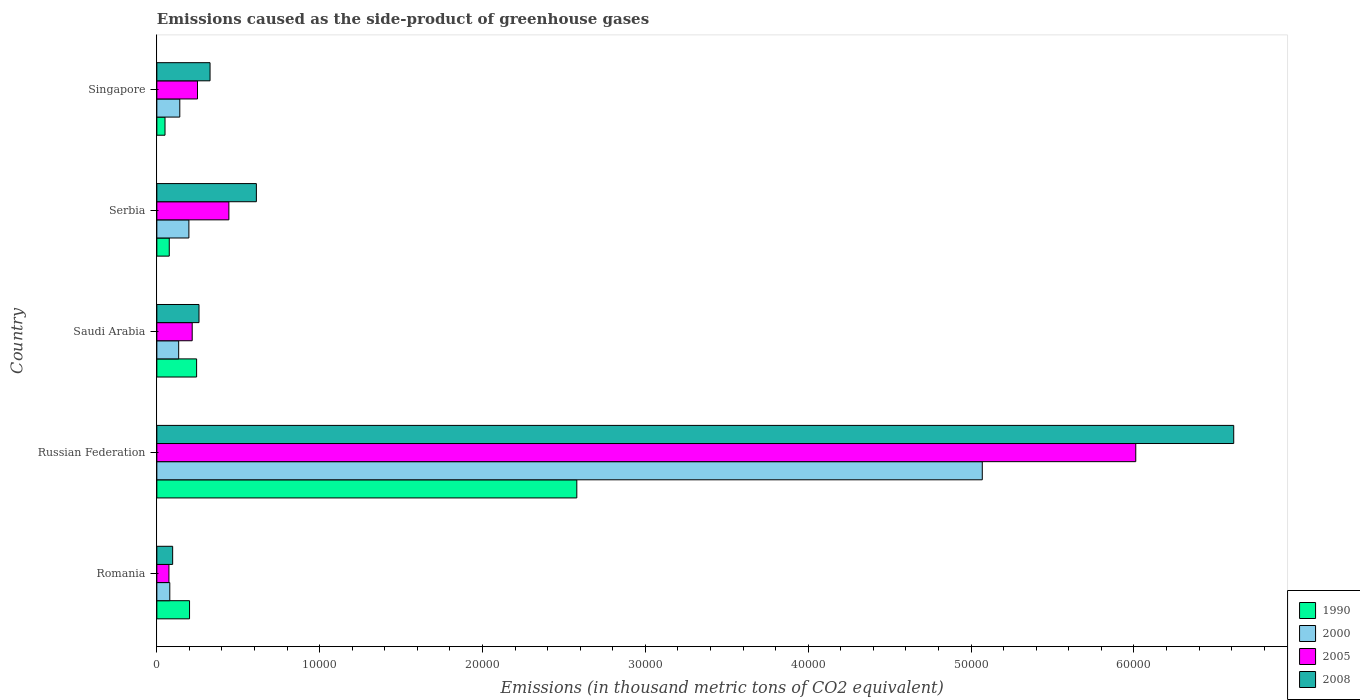How many different coloured bars are there?
Give a very brief answer. 4. What is the label of the 3rd group of bars from the top?
Offer a terse response. Saudi Arabia. What is the emissions caused as the side-product of greenhouse gases in 1990 in Russian Federation?
Keep it short and to the point. 2.58e+04. Across all countries, what is the maximum emissions caused as the side-product of greenhouse gases in 1990?
Provide a succinct answer. 2.58e+04. Across all countries, what is the minimum emissions caused as the side-product of greenhouse gases in 1990?
Provide a short and direct response. 501.5. In which country was the emissions caused as the side-product of greenhouse gases in 1990 maximum?
Provide a short and direct response. Russian Federation. In which country was the emissions caused as the side-product of greenhouse gases in 2005 minimum?
Ensure brevity in your answer.  Romania. What is the total emissions caused as the side-product of greenhouse gases in 1990 in the graph?
Your answer should be compact. 3.15e+04. What is the difference between the emissions caused as the side-product of greenhouse gases in 1990 in Russian Federation and that in Singapore?
Your answer should be compact. 2.53e+04. What is the difference between the emissions caused as the side-product of greenhouse gases in 2008 in Serbia and the emissions caused as the side-product of greenhouse gases in 1990 in Romania?
Give a very brief answer. 4103.6. What is the average emissions caused as the side-product of greenhouse gases in 1990 per country?
Your answer should be very brief. 6300.32. What is the difference between the emissions caused as the side-product of greenhouse gases in 2008 and emissions caused as the side-product of greenhouse gases in 2005 in Saudi Arabia?
Your answer should be very brief. 417.6. In how many countries, is the emissions caused as the side-product of greenhouse gases in 2008 greater than 54000 thousand metric tons?
Offer a very short reply. 1. What is the ratio of the emissions caused as the side-product of greenhouse gases in 2000 in Russian Federation to that in Serbia?
Provide a succinct answer. 25.75. Is the emissions caused as the side-product of greenhouse gases in 2000 in Serbia less than that in Singapore?
Keep it short and to the point. No. What is the difference between the highest and the second highest emissions caused as the side-product of greenhouse gases in 1990?
Offer a very short reply. 2.33e+04. What is the difference between the highest and the lowest emissions caused as the side-product of greenhouse gases in 2000?
Offer a very short reply. 4.99e+04. Is the sum of the emissions caused as the side-product of greenhouse gases in 1990 in Romania and Singapore greater than the maximum emissions caused as the side-product of greenhouse gases in 2008 across all countries?
Offer a very short reply. No. Is it the case that in every country, the sum of the emissions caused as the side-product of greenhouse gases in 2008 and emissions caused as the side-product of greenhouse gases in 2000 is greater than the sum of emissions caused as the side-product of greenhouse gases in 2005 and emissions caused as the side-product of greenhouse gases in 1990?
Your response must be concise. No. What does the 2nd bar from the bottom in Saudi Arabia represents?
Provide a short and direct response. 2000. Is it the case that in every country, the sum of the emissions caused as the side-product of greenhouse gases in 1990 and emissions caused as the side-product of greenhouse gases in 2008 is greater than the emissions caused as the side-product of greenhouse gases in 2000?
Offer a very short reply. Yes. Are all the bars in the graph horizontal?
Your response must be concise. Yes. Are the values on the major ticks of X-axis written in scientific E-notation?
Offer a very short reply. No. Does the graph contain any zero values?
Your answer should be compact. No. Where does the legend appear in the graph?
Your response must be concise. Bottom right. How many legend labels are there?
Your response must be concise. 4. What is the title of the graph?
Keep it short and to the point. Emissions caused as the side-product of greenhouse gases. What is the label or title of the X-axis?
Provide a succinct answer. Emissions (in thousand metric tons of CO2 equivalent). What is the Emissions (in thousand metric tons of CO2 equivalent) of 1990 in Romania?
Ensure brevity in your answer.  2007.7. What is the Emissions (in thousand metric tons of CO2 equivalent) of 2000 in Romania?
Ensure brevity in your answer.  795.1. What is the Emissions (in thousand metric tons of CO2 equivalent) in 2005 in Romania?
Provide a succinct answer. 742.3. What is the Emissions (in thousand metric tons of CO2 equivalent) in 2008 in Romania?
Keep it short and to the point. 970.3. What is the Emissions (in thousand metric tons of CO2 equivalent) in 1990 in Russian Federation?
Offer a very short reply. 2.58e+04. What is the Emissions (in thousand metric tons of CO2 equivalent) in 2000 in Russian Federation?
Your response must be concise. 5.07e+04. What is the Emissions (in thousand metric tons of CO2 equivalent) of 2005 in Russian Federation?
Provide a succinct answer. 6.01e+04. What is the Emissions (in thousand metric tons of CO2 equivalent) in 2008 in Russian Federation?
Your answer should be very brief. 6.61e+04. What is the Emissions (in thousand metric tons of CO2 equivalent) in 1990 in Saudi Arabia?
Give a very brief answer. 2441.4. What is the Emissions (in thousand metric tons of CO2 equivalent) in 2000 in Saudi Arabia?
Keep it short and to the point. 1340.1. What is the Emissions (in thousand metric tons of CO2 equivalent) in 2005 in Saudi Arabia?
Give a very brief answer. 2170.7. What is the Emissions (in thousand metric tons of CO2 equivalent) of 2008 in Saudi Arabia?
Your answer should be compact. 2588.3. What is the Emissions (in thousand metric tons of CO2 equivalent) in 1990 in Serbia?
Your response must be concise. 762.4. What is the Emissions (in thousand metric tons of CO2 equivalent) of 2000 in Serbia?
Your response must be concise. 1968.1. What is the Emissions (in thousand metric tons of CO2 equivalent) in 2005 in Serbia?
Your answer should be compact. 4422.8. What is the Emissions (in thousand metric tons of CO2 equivalent) in 2008 in Serbia?
Make the answer very short. 6111.3. What is the Emissions (in thousand metric tons of CO2 equivalent) in 1990 in Singapore?
Offer a very short reply. 501.5. What is the Emissions (in thousand metric tons of CO2 equivalent) in 2000 in Singapore?
Provide a succinct answer. 1409.6. What is the Emissions (in thousand metric tons of CO2 equivalent) of 2005 in Singapore?
Make the answer very short. 2496.4. What is the Emissions (in thousand metric tons of CO2 equivalent) in 2008 in Singapore?
Keep it short and to the point. 3266.4. Across all countries, what is the maximum Emissions (in thousand metric tons of CO2 equivalent) in 1990?
Your answer should be compact. 2.58e+04. Across all countries, what is the maximum Emissions (in thousand metric tons of CO2 equivalent) of 2000?
Your answer should be very brief. 5.07e+04. Across all countries, what is the maximum Emissions (in thousand metric tons of CO2 equivalent) in 2005?
Offer a very short reply. 6.01e+04. Across all countries, what is the maximum Emissions (in thousand metric tons of CO2 equivalent) of 2008?
Keep it short and to the point. 6.61e+04. Across all countries, what is the minimum Emissions (in thousand metric tons of CO2 equivalent) of 1990?
Your answer should be compact. 501.5. Across all countries, what is the minimum Emissions (in thousand metric tons of CO2 equivalent) of 2000?
Your answer should be compact. 795.1. Across all countries, what is the minimum Emissions (in thousand metric tons of CO2 equivalent) in 2005?
Provide a succinct answer. 742.3. Across all countries, what is the minimum Emissions (in thousand metric tons of CO2 equivalent) of 2008?
Provide a short and direct response. 970.3. What is the total Emissions (in thousand metric tons of CO2 equivalent) of 1990 in the graph?
Ensure brevity in your answer.  3.15e+04. What is the total Emissions (in thousand metric tons of CO2 equivalent) of 2000 in the graph?
Provide a short and direct response. 5.62e+04. What is the total Emissions (in thousand metric tons of CO2 equivalent) of 2005 in the graph?
Ensure brevity in your answer.  6.99e+04. What is the total Emissions (in thousand metric tons of CO2 equivalent) in 2008 in the graph?
Your response must be concise. 7.91e+04. What is the difference between the Emissions (in thousand metric tons of CO2 equivalent) in 1990 in Romania and that in Russian Federation?
Provide a succinct answer. -2.38e+04. What is the difference between the Emissions (in thousand metric tons of CO2 equivalent) of 2000 in Romania and that in Russian Federation?
Ensure brevity in your answer.  -4.99e+04. What is the difference between the Emissions (in thousand metric tons of CO2 equivalent) in 2005 in Romania and that in Russian Federation?
Your answer should be compact. -5.94e+04. What is the difference between the Emissions (in thousand metric tons of CO2 equivalent) in 2008 in Romania and that in Russian Federation?
Give a very brief answer. -6.52e+04. What is the difference between the Emissions (in thousand metric tons of CO2 equivalent) in 1990 in Romania and that in Saudi Arabia?
Make the answer very short. -433.7. What is the difference between the Emissions (in thousand metric tons of CO2 equivalent) of 2000 in Romania and that in Saudi Arabia?
Offer a very short reply. -545. What is the difference between the Emissions (in thousand metric tons of CO2 equivalent) of 2005 in Romania and that in Saudi Arabia?
Provide a short and direct response. -1428.4. What is the difference between the Emissions (in thousand metric tons of CO2 equivalent) in 2008 in Romania and that in Saudi Arabia?
Provide a succinct answer. -1618. What is the difference between the Emissions (in thousand metric tons of CO2 equivalent) in 1990 in Romania and that in Serbia?
Offer a terse response. 1245.3. What is the difference between the Emissions (in thousand metric tons of CO2 equivalent) in 2000 in Romania and that in Serbia?
Make the answer very short. -1173. What is the difference between the Emissions (in thousand metric tons of CO2 equivalent) of 2005 in Romania and that in Serbia?
Give a very brief answer. -3680.5. What is the difference between the Emissions (in thousand metric tons of CO2 equivalent) in 2008 in Romania and that in Serbia?
Your answer should be very brief. -5141. What is the difference between the Emissions (in thousand metric tons of CO2 equivalent) of 1990 in Romania and that in Singapore?
Your answer should be compact. 1506.2. What is the difference between the Emissions (in thousand metric tons of CO2 equivalent) of 2000 in Romania and that in Singapore?
Give a very brief answer. -614.5. What is the difference between the Emissions (in thousand metric tons of CO2 equivalent) in 2005 in Romania and that in Singapore?
Offer a very short reply. -1754.1. What is the difference between the Emissions (in thousand metric tons of CO2 equivalent) in 2008 in Romania and that in Singapore?
Offer a very short reply. -2296.1. What is the difference between the Emissions (in thousand metric tons of CO2 equivalent) of 1990 in Russian Federation and that in Saudi Arabia?
Keep it short and to the point. 2.33e+04. What is the difference between the Emissions (in thousand metric tons of CO2 equivalent) of 2000 in Russian Federation and that in Saudi Arabia?
Provide a short and direct response. 4.93e+04. What is the difference between the Emissions (in thousand metric tons of CO2 equivalent) in 2005 in Russian Federation and that in Saudi Arabia?
Provide a short and direct response. 5.79e+04. What is the difference between the Emissions (in thousand metric tons of CO2 equivalent) of 2008 in Russian Federation and that in Saudi Arabia?
Provide a short and direct response. 6.35e+04. What is the difference between the Emissions (in thousand metric tons of CO2 equivalent) in 1990 in Russian Federation and that in Serbia?
Your response must be concise. 2.50e+04. What is the difference between the Emissions (in thousand metric tons of CO2 equivalent) in 2000 in Russian Federation and that in Serbia?
Your answer should be compact. 4.87e+04. What is the difference between the Emissions (in thousand metric tons of CO2 equivalent) of 2005 in Russian Federation and that in Serbia?
Offer a terse response. 5.57e+04. What is the difference between the Emissions (in thousand metric tons of CO2 equivalent) of 2008 in Russian Federation and that in Serbia?
Your answer should be compact. 6.00e+04. What is the difference between the Emissions (in thousand metric tons of CO2 equivalent) in 1990 in Russian Federation and that in Singapore?
Offer a terse response. 2.53e+04. What is the difference between the Emissions (in thousand metric tons of CO2 equivalent) in 2000 in Russian Federation and that in Singapore?
Your response must be concise. 4.93e+04. What is the difference between the Emissions (in thousand metric tons of CO2 equivalent) of 2005 in Russian Federation and that in Singapore?
Offer a terse response. 5.76e+04. What is the difference between the Emissions (in thousand metric tons of CO2 equivalent) of 2008 in Russian Federation and that in Singapore?
Offer a terse response. 6.29e+04. What is the difference between the Emissions (in thousand metric tons of CO2 equivalent) in 1990 in Saudi Arabia and that in Serbia?
Your answer should be compact. 1679. What is the difference between the Emissions (in thousand metric tons of CO2 equivalent) in 2000 in Saudi Arabia and that in Serbia?
Your answer should be compact. -628. What is the difference between the Emissions (in thousand metric tons of CO2 equivalent) of 2005 in Saudi Arabia and that in Serbia?
Keep it short and to the point. -2252.1. What is the difference between the Emissions (in thousand metric tons of CO2 equivalent) of 2008 in Saudi Arabia and that in Serbia?
Your answer should be very brief. -3523. What is the difference between the Emissions (in thousand metric tons of CO2 equivalent) in 1990 in Saudi Arabia and that in Singapore?
Your answer should be compact. 1939.9. What is the difference between the Emissions (in thousand metric tons of CO2 equivalent) in 2000 in Saudi Arabia and that in Singapore?
Your answer should be very brief. -69.5. What is the difference between the Emissions (in thousand metric tons of CO2 equivalent) of 2005 in Saudi Arabia and that in Singapore?
Provide a succinct answer. -325.7. What is the difference between the Emissions (in thousand metric tons of CO2 equivalent) of 2008 in Saudi Arabia and that in Singapore?
Ensure brevity in your answer.  -678.1. What is the difference between the Emissions (in thousand metric tons of CO2 equivalent) of 1990 in Serbia and that in Singapore?
Ensure brevity in your answer.  260.9. What is the difference between the Emissions (in thousand metric tons of CO2 equivalent) in 2000 in Serbia and that in Singapore?
Offer a terse response. 558.5. What is the difference between the Emissions (in thousand metric tons of CO2 equivalent) of 2005 in Serbia and that in Singapore?
Give a very brief answer. 1926.4. What is the difference between the Emissions (in thousand metric tons of CO2 equivalent) of 2008 in Serbia and that in Singapore?
Keep it short and to the point. 2844.9. What is the difference between the Emissions (in thousand metric tons of CO2 equivalent) in 1990 in Romania and the Emissions (in thousand metric tons of CO2 equivalent) in 2000 in Russian Federation?
Keep it short and to the point. -4.87e+04. What is the difference between the Emissions (in thousand metric tons of CO2 equivalent) in 1990 in Romania and the Emissions (in thousand metric tons of CO2 equivalent) in 2005 in Russian Federation?
Give a very brief answer. -5.81e+04. What is the difference between the Emissions (in thousand metric tons of CO2 equivalent) of 1990 in Romania and the Emissions (in thousand metric tons of CO2 equivalent) of 2008 in Russian Federation?
Ensure brevity in your answer.  -6.41e+04. What is the difference between the Emissions (in thousand metric tons of CO2 equivalent) in 2000 in Romania and the Emissions (in thousand metric tons of CO2 equivalent) in 2005 in Russian Federation?
Give a very brief answer. -5.93e+04. What is the difference between the Emissions (in thousand metric tons of CO2 equivalent) of 2000 in Romania and the Emissions (in thousand metric tons of CO2 equivalent) of 2008 in Russian Federation?
Offer a terse response. -6.53e+04. What is the difference between the Emissions (in thousand metric tons of CO2 equivalent) of 2005 in Romania and the Emissions (in thousand metric tons of CO2 equivalent) of 2008 in Russian Federation?
Your answer should be compact. -6.54e+04. What is the difference between the Emissions (in thousand metric tons of CO2 equivalent) in 1990 in Romania and the Emissions (in thousand metric tons of CO2 equivalent) in 2000 in Saudi Arabia?
Provide a short and direct response. 667.6. What is the difference between the Emissions (in thousand metric tons of CO2 equivalent) in 1990 in Romania and the Emissions (in thousand metric tons of CO2 equivalent) in 2005 in Saudi Arabia?
Offer a terse response. -163. What is the difference between the Emissions (in thousand metric tons of CO2 equivalent) in 1990 in Romania and the Emissions (in thousand metric tons of CO2 equivalent) in 2008 in Saudi Arabia?
Your answer should be compact. -580.6. What is the difference between the Emissions (in thousand metric tons of CO2 equivalent) of 2000 in Romania and the Emissions (in thousand metric tons of CO2 equivalent) of 2005 in Saudi Arabia?
Give a very brief answer. -1375.6. What is the difference between the Emissions (in thousand metric tons of CO2 equivalent) in 2000 in Romania and the Emissions (in thousand metric tons of CO2 equivalent) in 2008 in Saudi Arabia?
Provide a succinct answer. -1793.2. What is the difference between the Emissions (in thousand metric tons of CO2 equivalent) of 2005 in Romania and the Emissions (in thousand metric tons of CO2 equivalent) of 2008 in Saudi Arabia?
Your answer should be compact. -1846. What is the difference between the Emissions (in thousand metric tons of CO2 equivalent) in 1990 in Romania and the Emissions (in thousand metric tons of CO2 equivalent) in 2000 in Serbia?
Make the answer very short. 39.6. What is the difference between the Emissions (in thousand metric tons of CO2 equivalent) in 1990 in Romania and the Emissions (in thousand metric tons of CO2 equivalent) in 2005 in Serbia?
Your answer should be very brief. -2415.1. What is the difference between the Emissions (in thousand metric tons of CO2 equivalent) in 1990 in Romania and the Emissions (in thousand metric tons of CO2 equivalent) in 2008 in Serbia?
Keep it short and to the point. -4103.6. What is the difference between the Emissions (in thousand metric tons of CO2 equivalent) of 2000 in Romania and the Emissions (in thousand metric tons of CO2 equivalent) of 2005 in Serbia?
Make the answer very short. -3627.7. What is the difference between the Emissions (in thousand metric tons of CO2 equivalent) of 2000 in Romania and the Emissions (in thousand metric tons of CO2 equivalent) of 2008 in Serbia?
Your response must be concise. -5316.2. What is the difference between the Emissions (in thousand metric tons of CO2 equivalent) in 2005 in Romania and the Emissions (in thousand metric tons of CO2 equivalent) in 2008 in Serbia?
Make the answer very short. -5369. What is the difference between the Emissions (in thousand metric tons of CO2 equivalent) in 1990 in Romania and the Emissions (in thousand metric tons of CO2 equivalent) in 2000 in Singapore?
Offer a terse response. 598.1. What is the difference between the Emissions (in thousand metric tons of CO2 equivalent) of 1990 in Romania and the Emissions (in thousand metric tons of CO2 equivalent) of 2005 in Singapore?
Offer a terse response. -488.7. What is the difference between the Emissions (in thousand metric tons of CO2 equivalent) in 1990 in Romania and the Emissions (in thousand metric tons of CO2 equivalent) in 2008 in Singapore?
Your response must be concise. -1258.7. What is the difference between the Emissions (in thousand metric tons of CO2 equivalent) of 2000 in Romania and the Emissions (in thousand metric tons of CO2 equivalent) of 2005 in Singapore?
Your answer should be very brief. -1701.3. What is the difference between the Emissions (in thousand metric tons of CO2 equivalent) of 2000 in Romania and the Emissions (in thousand metric tons of CO2 equivalent) of 2008 in Singapore?
Ensure brevity in your answer.  -2471.3. What is the difference between the Emissions (in thousand metric tons of CO2 equivalent) in 2005 in Romania and the Emissions (in thousand metric tons of CO2 equivalent) in 2008 in Singapore?
Ensure brevity in your answer.  -2524.1. What is the difference between the Emissions (in thousand metric tons of CO2 equivalent) of 1990 in Russian Federation and the Emissions (in thousand metric tons of CO2 equivalent) of 2000 in Saudi Arabia?
Your response must be concise. 2.44e+04. What is the difference between the Emissions (in thousand metric tons of CO2 equivalent) of 1990 in Russian Federation and the Emissions (in thousand metric tons of CO2 equivalent) of 2005 in Saudi Arabia?
Ensure brevity in your answer.  2.36e+04. What is the difference between the Emissions (in thousand metric tons of CO2 equivalent) in 1990 in Russian Federation and the Emissions (in thousand metric tons of CO2 equivalent) in 2008 in Saudi Arabia?
Make the answer very short. 2.32e+04. What is the difference between the Emissions (in thousand metric tons of CO2 equivalent) of 2000 in Russian Federation and the Emissions (in thousand metric tons of CO2 equivalent) of 2005 in Saudi Arabia?
Ensure brevity in your answer.  4.85e+04. What is the difference between the Emissions (in thousand metric tons of CO2 equivalent) of 2000 in Russian Federation and the Emissions (in thousand metric tons of CO2 equivalent) of 2008 in Saudi Arabia?
Give a very brief answer. 4.81e+04. What is the difference between the Emissions (in thousand metric tons of CO2 equivalent) of 2005 in Russian Federation and the Emissions (in thousand metric tons of CO2 equivalent) of 2008 in Saudi Arabia?
Your response must be concise. 5.75e+04. What is the difference between the Emissions (in thousand metric tons of CO2 equivalent) of 1990 in Russian Federation and the Emissions (in thousand metric tons of CO2 equivalent) of 2000 in Serbia?
Your answer should be very brief. 2.38e+04. What is the difference between the Emissions (in thousand metric tons of CO2 equivalent) in 1990 in Russian Federation and the Emissions (in thousand metric tons of CO2 equivalent) in 2005 in Serbia?
Your response must be concise. 2.14e+04. What is the difference between the Emissions (in thousand metric tons of CO2 equivalent) of 1990 in Russian Federation and the Emissions (in thousand metric tons of CO2 equivalent) of 2008 in Serbia?
Your answer should be very brief. 1.97e+04. What is the difference between the Emissions (in thousand metric tons of CO2 equivalent) of 2000 in Russian Federation and the Emissions (in thousand metric tons of CO2 equivalent) of 2005 in Serbia?
Give a very brief answer. 4.63e+04. What is the difference between the Emissions (in thousand metric tons of CO2 equivalent) of 2000 in Russian Federation and the Emissions (in thousand metric tons of CO2 equivalent) of 2008 in Serbia?
Your response must be concise. 4.46e+04. What is the difference between the Emissions (in thousand metric tons of CO2 equivalent) in 2005 in Russian Federation and the Emissions (in thousand metric tons of CO2 equivalent) in 2008 in Serbia?
Keep it short and to the point. 5.40e+04. What is the difference between the Emissions (in thousand metric tons of CO2 equivalent) of 1990 in Russian Federation and the Emissions (in thousand metric tons of CO2 equivalent) of 2000 in Singapore?
Your answer should be compact. 2.44e+04. What is the difference between the Emissions (in thousand metric tons of CO2 equivalent) of 1990 in Russian Federation and the Emissions (in thousand metric tons of CO2 equivalent) of 2005 in Singapore?
Your answer should be very brief. 2.33e+04. What is the difference between the Emissions (in thousand metric tons of CO2 equivalent) in 1990 in Russian Federation and the Emissions (in thousand metric tons of CO2 equivalent) in 2008 in Singapore?
Your answer should be very brief. 2.25e+04. What is the difference between the Emissions (in thousand metric tons of CO2 equivalent) of 2000 in Russian Federation and the Emissions (in thousand metric tons of CO2 equivalent) of 2005 in Singapore?
Offer a very short reply. 4.82e+04. What is the difference between the Emissions (in thousand metric tons of CO2 equivalent) of 2000 in Russian Federation and the Emissions (in thousand metric tons of CO2 equivalent) of 2008 in Singapore?
Provide a short and direct response. 4.74e+04. What is the difference between the Emissions (in thousand metric tons of CO2 equivalent) in 2005 in Russian Federation and the Emissions (in thousand metric tons of CO2 equivalent) in 2008 in Singapore?
Ensure brevity in your answer.  5.68e+04. What is the difference between the Emissions (in thousand metric tons of CO2 equivalent) of 1990 in Saudi Arabia and the Emissions (in thousand metric tons of CO2 equivalent) of 2000 in Serbia?
Ensure brevity in your answer.  473.3. What is the difference between the Emissions (in thousand metric tons of CO2 equivalent) in 1990 in Saudi Arabia and the Emissions (in thousand metric tons of CO2 equivalent) in 2005 in Serbia?
Keep it short and to the point. -1981.4. What is the difference between the Emissions (in thousand metric tons of CO2 equivalent) in 1990 in Saudi Arabia and the Emissions (in thousand metric tons of CO2 equivalent) in 2008 in Serbia?
Your answer should be very brief. -3669.9. What is the difference between the Emissions (in thousand metric tons of CO2 equivalent) of 2000 in Saudi Arabia and the Emissions (in thousand metric tons of CO2 equivalent) of 2005 in Serbia?
Provide a succinct answer. -3082.7. What is the difference between the Emissions (in thousand metric tons of CO2 equivalent) of 2000 in Saudi Arabia and the Emissions (in thousand metric tons of CO2 equivalent) of 2008 in Serbia?
Offer a terse response. -4771.2. What is the difference between the Emissions (in thousand metric tons of CO2 equivalent) of 2005 in Saudi Arabia and the Emissions (in thousand metric tons of CO2 equivalent) of 2008 in Serbia?
Provide a short and direct response. -3940.6. What is the difference between the Emissions (in thousand metric tons of CO2 equivalent) of 1990 in Saudi Arabia and the Emissions (in thousand metric tons of CO2 equivalent) of 2000 in Singapore?
Offer a terse response. 1031.8. What is the difference between the Emissions (in thousand metric tons of CO2 equivalent) of 1990 in Saudi Arabia and the Emissions (in thousand metric tons of CO2 equivalent) of 2005 in Singapore?
Give a very brief answer. -55. What is the difference between the Emissions (in thousand metric tons of CO2 equivalent) in 1990 in Saudi Arabia and the Emissions (in thousand metric tons of CO2 equivalent) in 2008 in Singapore?
Ensure brevity in your answer.  -825. What is the difference between the Emissions (in thousand metric tons of CO2 equivalent) of 2000 in Saudi Arabia and the Emissions (in thousand metric tons of CO2 equivalent) of 2005 in Singapore?
Your answer should be compact. -1156.3. What is the difference between the Emissions (in thousand metric tons of CO2 equivalent) of 2000 in Saudi Arabia and the Emissions (in thousand metric tons of CO2 equivalent) of 2008 in Singapore?
Ensure brevity in your answer.  -1926.3. What is the difference between the Emissions (in thousand metric tons of CO2 equivalent) of 2005 in Saudi Arabia and the Emissions (in thousand metric tons of CO2 equivalent) of 2008 in Singapore?
Offer a terse response. -1095.7. What is the difference between the Emissions (in thousand metric tons of CO2 equivalent) of 1990 in Serbia and the Emissions (in thousand metric tons of CO2 equivalent) of 2000 in Singapore?
Offer a very short reply. -647.2. What is the difference between the Emissions (in thousand metric tons of CO2 equivalent) of 1990 in Serbia and the Emissions (in thousand metric tons of CO2 equivalent) of 2005 in Singapore?
Your answer should be compact. -1734. What is the difference between the Emissions (in thousand metric tons of CO2 equivalent) in 1990 in Serbia and the Emissions (in thousand metric tons of CO2 equivalent) in 2008 in Singapore?
Make the answer very short. -2504. What is the difference between the Emissions (in thousand metric tons of CO2 equivalent) in 2000 in Serbia and the Emissions (in thousand metric tons of CO2 equivalent) in 2005 in Singapore?
Make the answer very short. -528.3. What is the difference between the Emissions (in thousand metric tons of CO2 equivalent) of 2000 in Serbia and the Emissions (in thousand metric tons of CO2 equivalent) of 2008 in Singapore?
Make the answer very short. -1298.3. What is the difference between the Emissions (in thousand metric tons of CO2 equivalent) of 2005 in Serbia and the Emissions (in thousand metric tons of CO2 equivalent) of 2008 in Singapore?
Ensure brevity in your answer.  1156.4. What is the average Emissions (in thousand metric tons of CO2 equivalent) in 1990 per country?
Offer a very short reply. 6300.32. What is the average Emissions (in thousand metric tons of CO2 equivalent) in 2000 per country?
Offer a terse response. 1.12e+04. What is the average Emissions (in thousand metric tons of CO2 equivalent) of 2005 per country?
Keep it short and to the point. 1.40e+04. What is the average Emissions (in thousand metric tons of CO2 equivalent) of 2008 per country?
Your answer should be compact. 1.58e+04. What is the difference between the Emissions (in thousand metric tons of CO2 equivalent) in 1990 and Emissions (in thousand metric tons of CO2 equivalent) in 2000 in Romania?
Provide a succinct answer. 1212.6. What is the difference between the Emissions (in thousand metric tons of CO2 equivalent) in 1990 and Emissions (in thousand metric tons of CO2 equivalent) in 2005 in Romania?
Ensure brevity in your answer.  1265.4. What is the difference between the Emissions (in thousand metric tons of CO2 equivalent) of 1990 and Emissions (in thousand metric tons of CO2 equivalent) of 2008 in Romania?
Keep it short and to the point. 1037.4. What is the difference between the Emissions (in thousand metric tons of CO2 equivalent) in 2000 and Emissions (in thousand metric tons of CO2 equivalent) in 2005 in Romania?
Offer a very short reply. 52.8. What is the difference between the Emissions (in thousand metric tons of CO2 equivalent) of 2000 and Emissions (in thousand metric tons of CO2 equivalent) of 2008 in Romania?
Your response must be concise. -175.2. What is the difference between the Emissions (in thousand metric tons of CO2 equivalent) in 2005 and Emissions (in thousand metric tons of CO2 equivalent) in 2008 in Romania?
Give a very brief answer. -228. What is the difference between the Emissions (in thousand metric tons of CO2 equivalent) of 1990 and Emissions (in thousand metric tons of CO2 equivalent) of 2000 in Russian Federation?
Provide a short and direct response. -2.49e+04. What is the difference between the Emissions (in thousand metric tons of CO2 equivalent) of 1990 and Emissions (in thousand metric tons of CO2 equivalent) of 2005 in Russian Federation?
Give a very brief answer. -3.43e+04. What is the difference between the Emissions (in thousand metric tons of CO2 equivalent) in 1990 and Emissions (in thousand metric tons of CO2 equivalent) in 2008 in Russian Federation?
Make the answer very short. -4.03e+04. What is the difference between the Emissions (in thousand metric tons of CO2 equivalent) of 2000 and Emissions (in thousand metric tons of CO2 equivalent) of 2005 in Russian Federation?
Offer a terse response. -9424.5. What is the difference between the Emissions (in thousand metric tons of CO2 equivalent) in 2000 and Emissions (in thousand metric tons of CO2 equivalent) in 2008 in Russian Federation?
Keep it short and to the point. -1.54e+04. What is the difference between the Emissions (in thousand metric tons of CO2 equivalent) in 2005 and Emissions (in thousand metric tons of CO2 equivalent) in 2008 in Russian Federation?
Offer a terse response. -6015. What is the difference between the Emissions (in thousand metric tons of CO2 equivalent) of 1990 and Emissions (in thousand metric tons of CO2 equivalent) of 2000 in Saudi Arabia?
Offer a very short reply. 1101.3. What is the difference between the Emissions (in thousand metric tons of CO2 equivalent) in 1990 and Emissions (in thousand metric tons of CO2 equivalent) in 2005 in Saudi Arabia?
Offer a very short reply. 270.7. What is the difference between the Emissions (in thousand metric tons of CO2 equivalent) in 1990 and Emissions (in thousand metric tons of CO2 equivalent) in 2008 in Saudi Arabia?
Make the answer very short. -146.9. What is the difference between the Emissions (in thousand metric tons of CO2 equivalent) of 2000 and Emissions (in thousand metric tons of CO2 equivalent) of 2005 in Saudi Arabia?
Make the answer very short. -830.6. What is the difference between the Emissions (in thousand metric tons of CO2 equivalent) of 2000 and Emissions (in thousand metric tons of CO2 equivalent) of 2008 in Saudi Arabia?
Your response must be concise. -1248.2. What is the difference between the Emissions (in thousand metric tons of CO2 equivalent) of 2005 and Emissions (in thousand metric tons of CO2 equivalent) of 2008 in Saudi Arabia?
Your response must be concise. -417.6. What is the difference between the Emissions (in thousand metric tons of CO2 equivalent) in 1990 and Emissions (in thousand metric tons of CO2 equivalent) in 2000 in Serbia?
Give a very brief answer. -1205.7. What is the difference between the Emissions (in thousand metric tons of CO2 equivalent) in 1990 and Emissions (in thousand metric tons of CO2 equivalent) in 2005 in Serbia?
Make the answer very short. -3660.4. What is the difference between the Emissions (in thousand metric tons of CO2 equivalent) in 1990 and Emissions (in thousand metric tons of CO2 equivalent) in 2008 in Serbia?
Give a very brief answer. -5348.9. What is the difference between the Emissions (in thousand metric tons of CO2 equivalent) in 2000 and Emissions (in thousand metric tons of CO2 equivalent) in 2005 in Serbia?
Ensure brevity in your answer.  -2454.7. What is the difference between the Emissions (in thousand metric tons of CO2 equivalent) in 2000 and Emissions (in thousand metric tons of CO2 equivalent) in 2008 in Serbia?
Your response must be concise. -4143.2. What is the difference between the Emissions (in thousand metric tons of CO2 equivalent) of 2005 and Emissions (in thousand metric tons of CO2 equivalent) of 2008 in Serbia?
Provide a short and direct response. -1688.5. What is the difference between the Emissions (in thousand metric tons of CO2 equivalent) of 1990 and Emissions (in thousand metric tons of CO2 equivalent) of 2000 in Singapore?
Your answer should be very brief. -908.1. What is the difference between the Emissions (in thousand metric tons of CO2 equivalent) in 1990 and Emissions (in thousand metric tons of CO2 equivalent) in 2005 in Singapore?
Make the answer very short. -1994.9. What is the difference between the Emissions (in thousand metric tons of CO2 equivalent) in 1990 and Emissions (in thousand metric tons of CO2 equivalent) in 2008 in Singapore?
Provide a succinct answer. -2764.9. What is the difference between the Emissions (in thousand metric tons of CO2 equivalent) in 2000 and Emissions (in thousand metric tons of CO2 equivalent) in 2005 in Singapore?
Your response must be concise. -1086.8. What is the difference between the Emissions (in thousand metric tons of CO2 equivalent) in 2000 and Emissions (in thousand metric tons of CO2 equivalent) in 2008 in Singapore?
Give a very brief answer. -1856.8. What is the difference between the Emissions (in thousand metric tons of CO2 equivalent) of 2005 and Emissions (in thousand metric tons of CO2 equivalent) of 2008 in Singapore?
Provide a short and direct response. -770. What is the ratio of the Emissions (in thousand metric tons of CO2 equivalent) of 1990 in Romania to that in Russian Federation?
Offer a very short reply. 0.08. What is the ratio of the Emissions (in thousand metric tons of CO2 equivalent) in 2000 in Romania to that in Russian Federation?
Provide a succinct answer. 0.02. What is the ratio of the Emissions (in thousand metric tons of CO2 equivalent) in 2005 in Romania to that in Russian Federation?
Offer a very short reply. 0.01. What is the ratio of the Emissions (in thousand metric tons of CO2 equivalent) in 2008 in Romania to that in Russian Federation?
Offer a very short reply. 0.01. What is the ratio of the Emissions (in thousand metric tons of CO2 equivalent) of 1990 in Romania to that in Saudi Arabia?
Provide a succinct answer. 0.82. What is the ratio of the Emissions (in thousand metric tons of CO2 equivalent) in 2000 in Romania to that in Saudi Arabia?
Your answer should be compact. 0.59. What is the ratio of the Emissions (in thousand metric tons of CO2 equivalent) of 2005 in Romania to that in Saudi Arabia?
Give a very brief answer. 0.34. What is the ratio of the Emissions (in thousand metric tons of CO2 equivalent) of 2008 in Romania to that in Saudi Arabia?
Give a very brief answer. 0.37. What is the ratio of the Emissions (in thousand metric tons of CO2 equivalent) in 1990 in Romania to that in Serbia?
Your answer should be compact. 2.63. What is the ratio of the Emissions (in thousand metric tons of CO2 equivalent) in 2000 in Romania to that in Serbia?
Ensure brevity in your answer.  0.4. What is the ratio of the Emissions (in thousand metric tons of CO2 equivalent) of 2005 in Romania to that in Serbia?
Offer a terse response. 0.17. What is the ratio of the Emissions (in thousand metric tons of CO2 equivalent) of 2008 in Romania to that in Serbia?
Offer a very short reply. 0.16. What is the ratio of the Emissions (in thousand metric tons of CO2 equivalent) of 1990 in Romania to that in Singapore?
Your answer should be compact. 4. What is the ratio of the Emissions (in thousand metric tons of CO2 equivalent) in 2000 in Romania to that in Singapore?
Your answer should be compact. 0.56. What is the ratio of the Emissions (in thousand metric tons of CO2 equivalent) of 2005 in Romania to that in Singapore?
Your answer should be compact. 0.3. What is the ratio of the Emissions (in thousand metric tons of CO2 equivalent) of 2008 in Romania to that in Singapore?
Offer a very short reply. 0.3. What is the ratio of the Emissions (in thousand metric tons of CO2 equivalent) in 1990 in Russian Federation to that in Saudi Arabia?
Give a very brief answer. 10.56. What is the ratio of the Emissions (in thousand metric tons of CO2 equivalent) of 2000 in Russian Federation to that in Saudi Arabia?
Provide a short and direct response. 37.82. What is the ratio of the Emissions (in thousand metric tons of CO2 equivalent) in 2005 in Russian Federation to that in Saudi Arabia?
Your answer should be very brief. 27.69. What is the ratio of the Emissions (in thousand metric tons of CO2 equivalent) of 2008 in Russian Federation to that in Saudi Arabia?
Ensure brevity in your answer.  25.55. What is the ratio of the Emissions (in thousand metric tons of CO2 equivalent) in 1990 in Russian Federation to that in Serbia?
Your answer should be compact. 33.83. What is the ratio of the Emissions (in thousand metric tons of CO2 equivalent) of 2000 in Russian Federation to that in Serbia?
Offer a terse response. 25.75. What is the ratio of the Emissions (in thousand metric tons of CO2 equivalent) in 2005 in Russian Federation to that in Serbia?
Offer a very short reply. 13.59. What is the ratio of the Emissions (in thousand metric tons of CO2 equivalent) in 2008 in Russian Federation to that in Serbia?
Offer a very short reply. 10.82. What is the ratio of the Emissions (in thousand metric tons of CO2 equivalent) of 1990 in Russian Federation to that in Singapore?
Offer a terse response. 51.42. What is the ratio of the Emissions (in thousand metric tons of CO2 equivalent) in 2000 in Russian Federation to that in Singapore?
Your response must be concise. 35.96. What is the ratio of the Emissions (in thousand metric tons of CO2 equivalent) in 2005 in Russian Federation to that in Singapore?
Your answer should be compact. 24.08. What is the ratio of the Emissions (in thousand metric tons of CO2 equivalent) in 2008 in Russian Federation to that in Singapore?
Keep it short and to the point. 20.24. What is the ratio of the Emissions (in thousand metric tons of CO2 equivalent) of 1990 in Saudi Arabia to that in Serbia?
Your response must be concise. 3.2. What is the ratio of the Emissions (in thousand metric tons of CO2 equivalent) of 2000 in Saudi Arabia to that in Serbia?
Make the answer very short. 0.68. What is the ratio of the Emissions (in thousand metric tons of CO2 equivalent) in 2005 in Saudi Arabia to that in Serbia?
Your answer should be compact. 0.49. What is the ratio of the Emissions (in thousand metric tons of CO2 equivalent) in 2008 in Saudi Arabia to that in Serbia?
Your answer should be compact. 0.42. What is the ratio of the Emissions (in thousand metric tons of CO2 equivalent) of 1990 in Saudi Arabia to that in Singapore?
Provide a succinct answer. 4.87. What is the ratio of the Emissions (in thousand metric tons of CO2 equivalent) of 2000 in Saudi Arabia to that in Singapore?
Provide a succinct answer. 0.95. What is the ratio of the Emissions (in thousand metric tons of CO2 equivalent) of 2005 in Saudi Arabia to that in Singapore?
Ensure brevity in your answer.  0.87. What is the ratio of the Emissions (in thousand metric tons of CO2 equivalent) in 2008 in Saudi Arabia to that in Singapore?
Ensure brevity in your answer.  0.79. What is the ratio of the Emissions (in thousand metric tons of CO2 equivalent) of 1990 in Serbia to that in Singapore?
Keep it short and to the point. 1.52. What is the ratio of the Emissions (in thousand metric tons of CO2 equivalent) in 2000 in Serbia to that in Singapore?
Keep it short and to the point. 1.4. What is the ratio of the Emissions (in thousand metric tons of CO2 equivalent) of 2005 in Serbia to that in Singapore?
Your answer should be very brief. 1.77. What is the ratio of the Emissions (in thousand metric tons of CO2 equivalent) in 2008 in Serbia to that in Singapore?
Offer a terse response. 1.87. What is the difference between the highest and the second highest Emissions (in thousand metric tons of CO2 equivalent) of 1990?
Your answer should be very brief. 2.33e+04. What is the difference between the highest and the second highest Emissions (in thousand metric tons of CO2 equivalent) of 2000?
Your response must be concise. 4.87e+04. What is the difference between the highest and the second highest Emissions (in thousand metric tons of CO2 equivalent) in 2005?
Ensure brevity in your answer.  5.57e+04. What is the difference between the highest and the second highest Emissions (in thousand metric tons of CO2 equivalent) of 2008?
Keep it short and to the point. 6.00e+04. What is the difference between the highest and the lowest Emissions (in thousand metric tons of CO2 equivalent) in 1990?
Make the answer very short. 2.53e+04. What is the difference between the highest and the lowest Emissions (in thousand metric tons of CO2 equivalent) in 2000?
Keep it short and to the point. 4.99e+04. What is the difference between the highest and the lowest Emissions (in thousand metric tons of CO2 equivalent) in 2005?
Keep it short and to the point. 5.94e+04. What is the difference between the highest and the lowest Emissions (in thousand metric tons of CO2 equivalent) in 2008?
Your answer should be very brief. 6.52e+04. 